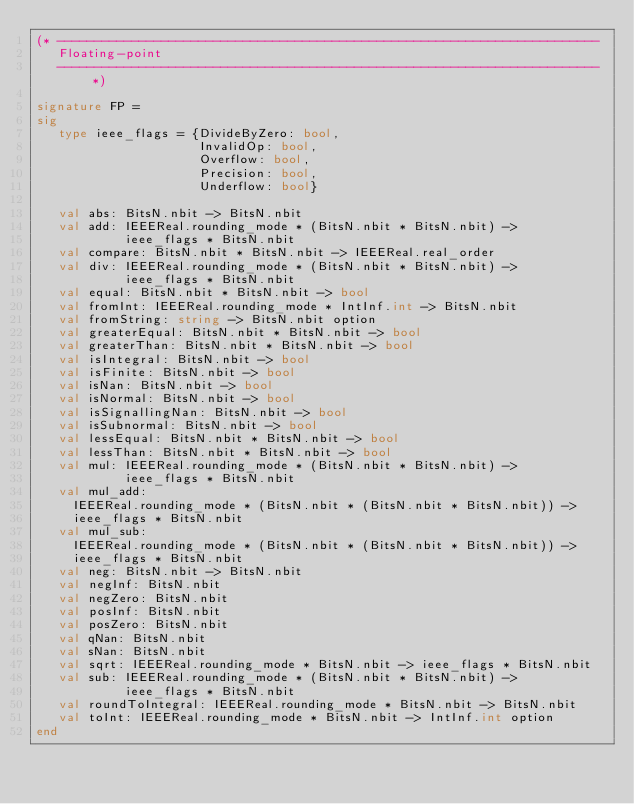<code> <loc_0><loc_0><loc_500><loc_500><_SML_>(* -------------------------------------------------------------------------
   Floating-point
   ------------------------------------------------------------------------- *)

signature FP =
sig
   type ieee_flags = {DivideByZero: bool,
                      InvalidOp: bool,
                      Overflow: bool,
                      Precision: bool,
                      Underflow: bool}

   val abs: BitsN.nbit -> BitsN.nbit
   val add: IEEEReal.rounding_mode * (BitsN.nbit * BitsN.nbit) ->
            ieee_flags * BitsN.nbit
   val compare: BitsN.nbit * BitsN.nbit -> IEEEReal.real_order
   val div: IEEEReal.rounding_mode * (BitsN.nbit * BitsN.nbit) ->
            ieee_flags * BitsN.nbit
   val equal: BitsN.nbit * BitsN.nbit -> bool
   val fromInt: IEEEReal.rounding_mode * IntInf.int -> BitsN.nbit
   val fromString: string -> BitsN.nbit option
   val greaterEqual: BitsN.nbit * BitsN.nbit -> bool
   val greaterThan: BitsN.nbit * BitsN.nbit -> bool
   val isIntegral: BitsN.nbit -> bool
   val isFinite: BitsN.nbit -> bool
   val isNan: BitsN.nbit -> bool
   val isNormal: BitsN.nbit -> bool
   val isSignallingNan: BitsN.nbit -> bool
   val isSubnormal: BitsN.nbit -> bool
   val lessEqual: BitsN.nbit * BitsN.nbit -> bool
   val lessThan: BitsN.nbit * BitsN.nbit -> bool
   val mul: IEEEReal.rounding_mode * (BitsN.nbit * BitsN.nbit) ->
            ieee_flags * BitsN.nbit
   val mul_add:
     IEEEReal.rounding_mode * (BitsN.nbit * (BitsN.nbit * BitsN.nbit)) ->
     ieee_flags * BitsN.nbit
   val mul_sub:
     IEEEReal.rounding_mode * (BitsN.nbit * (BitsN.nbit * BitsN.nbit)) ->
     ieee_flags * BitsN.nbit
   val neg: BitsN.nbit -> BitsN.nbit
   val negInf: BitsN.nbit
   val negZero: BitsN.nbit
   val posInf: BitsN.nbit
   val posZero: BitsN.nbit
   val qNan: BitsN.nbit
   val sNan: BitsN.nbit
   val sqrt: IEEEReal.rounding_mode * BitsN.nbit -> ieee_flags * BitsN.nbit
   val sub: IEEEReal.rounding_mode * (BitsN.nbit * BitsN.nbit) ->
            ieee_flags * BitsN.nbit
   val roundToIntegral: IEEEReal.rounding_mode * BitsN.nbit -> BitsN.nbit
   val toInt: IEEEReal.rounding_mode * BitsN.nbit -> IntInf.int option
end
</code> 